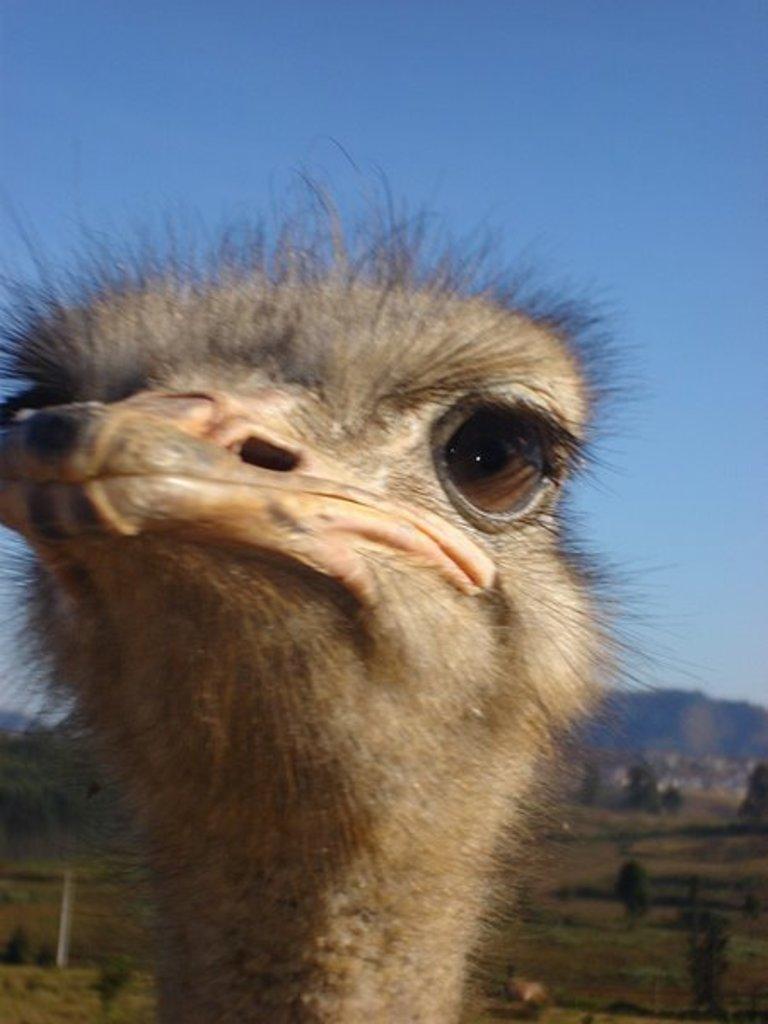How would you summarize this image in a sentence or two? In this image there is an animal. Behind few trees are on the grassland. Background there are hills. Top of the image there is sky. 